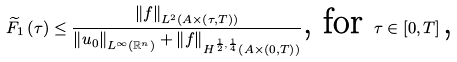Convert formula to latex. <formula><loc_0><loc_0><loc_500><loc_500>\widetilde { F } _ { 1 } \left ( \tau \right ) \leq \frac { \left \| f \right \| _ { L ^ { 2 } \left ( A \times \left ( \tau , T \right ) \right ) } } { \left \| u _ { 0 } \right \| _ { L ^ { \infty } \left ( \mathbb { R } ^ { n } \right ) } + \left \| f \right \| _ { H ^ { \frac { 1 } { 2 } , \frac { 1 } { 4 } } \left ( A \times \left ( 0 , T \right ) \right ) } } \text {, for } \tau \in \left [ 0 , T \right ] \text {,}</formula> 